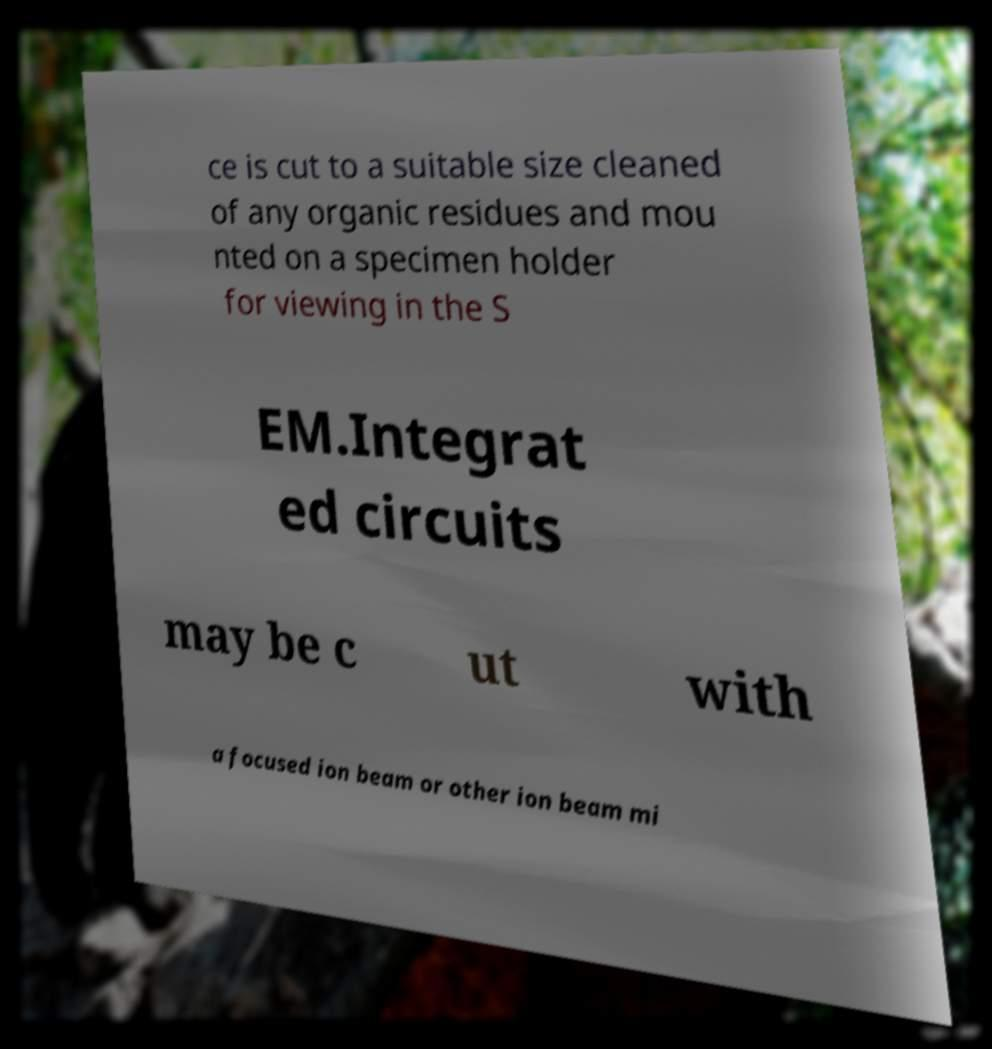What messages or text are displayed in this image? I need them in a readable, typed format. ce is cut to a suitable size cleaned of any organic residues and mou nted on a specimen holder for viewing in the S EM.Integrat ed circuits may be c ut with a focused ion beam or other ion beam mi 